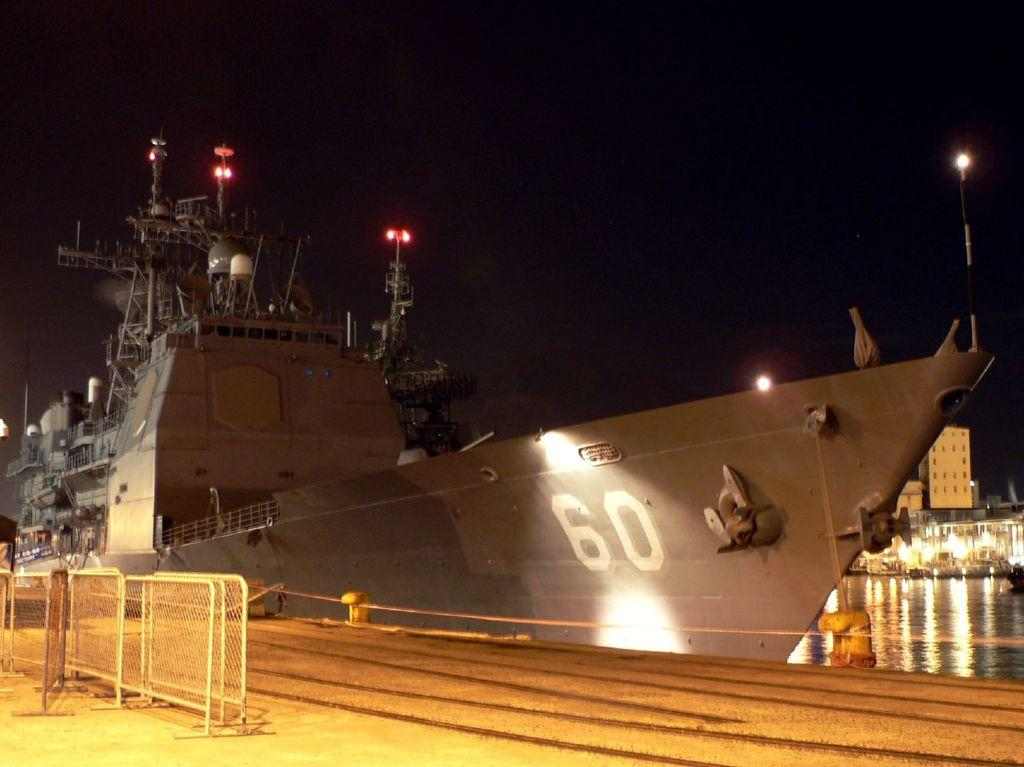Provide a one-sentence caption for the provided image. A large, grey military sea vessel marked with the number 60 is docked. 